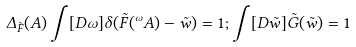Convert formula to latex. <formula><loc_0><loc_0><loc_500><loc_500>\Delta _ { \tilde { F } } ( A ) \int [ D \omega ] \delta ( \tilde { F } ( ^ { \omega } A ) - \tilde { w } ) = 1 ; \int [ D \tilde { w } ] \tilde { G } ( \tilde { w } ) = 1</formula> 